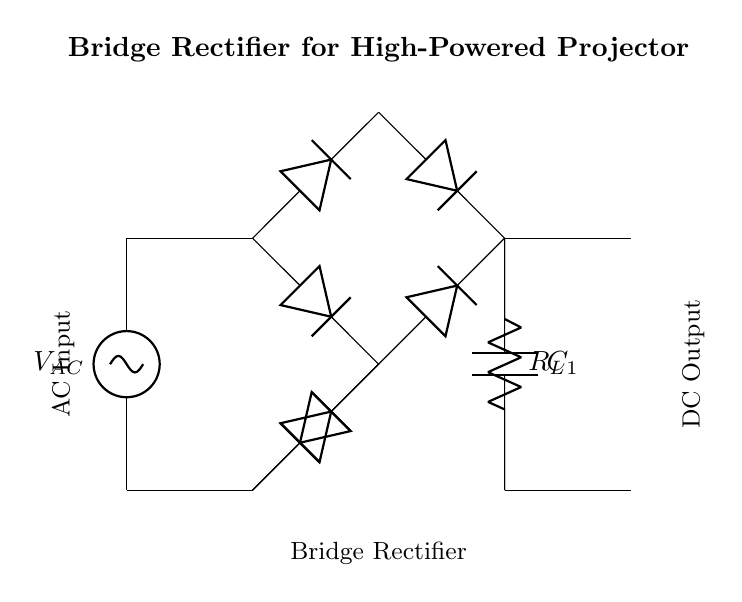What is the type of circuit shown? The circuit is a bridge rectifier, which is indicated by the arrangement of four diodes forming a bridge configuration to convert AC to DC.
Answer: bridge rectifier What components are used in this circuit? The components include diodes, a smoothing capacitor, and a load resistor, which are labeled in the diagram.
Answer: diodes, capacitor, resistor What is the purpose of the smoothing capacitor? The purpose of the smoothing capacitor is to reduce voltage fluctuations and provide a stable DC output by filtering the pulsating DC after rectification.
Answer: reduce voltage fluctuations How many diodes are used in the bridge rectifier? There are four diodes used, arranged in a bridge configuration, as seen in the diagram connecting the AC source to the load.
Answer: four What does the symbol labeled $R_L$ represent? The label $R_L$ represents the load resistor in the circuit, which is used to draw current and where the output DC voltage is measured.
Answer: load resistor What is the input voltage type for this circuit? The input voltage type is AC, which is indicated by the label on the voltage source at the beginning of the circuit.
Answer: AC Why is a bridge rectifier preferred for high power applications? A bridge rectifier is preferred because it allows rectification of both halves of the AC waveform, increasing efficiency and providing a better average output voltage for high power applications.
Answer: increased efficiency 